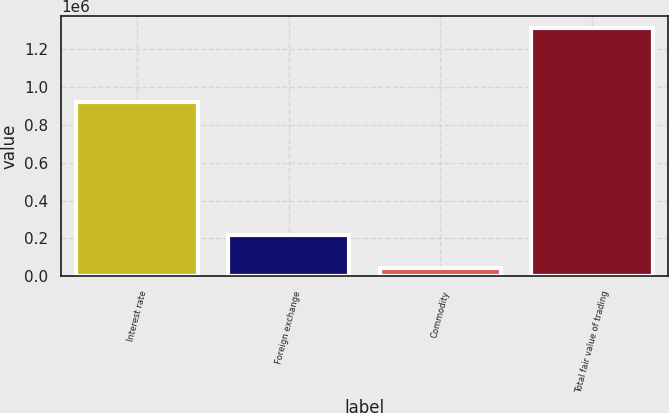Convert chart to OTSL. <chart><loc_0><loc_0><loc_500><loc_500><bar_chart><fcel>Interest rate<fcel>Foreign exchange<fcel>Commodity<fcel>Total fair value of trading<nl><fcel>921634<fcel>217722<fcel>45455<fcel>1.31127e+06<nl></chart> 